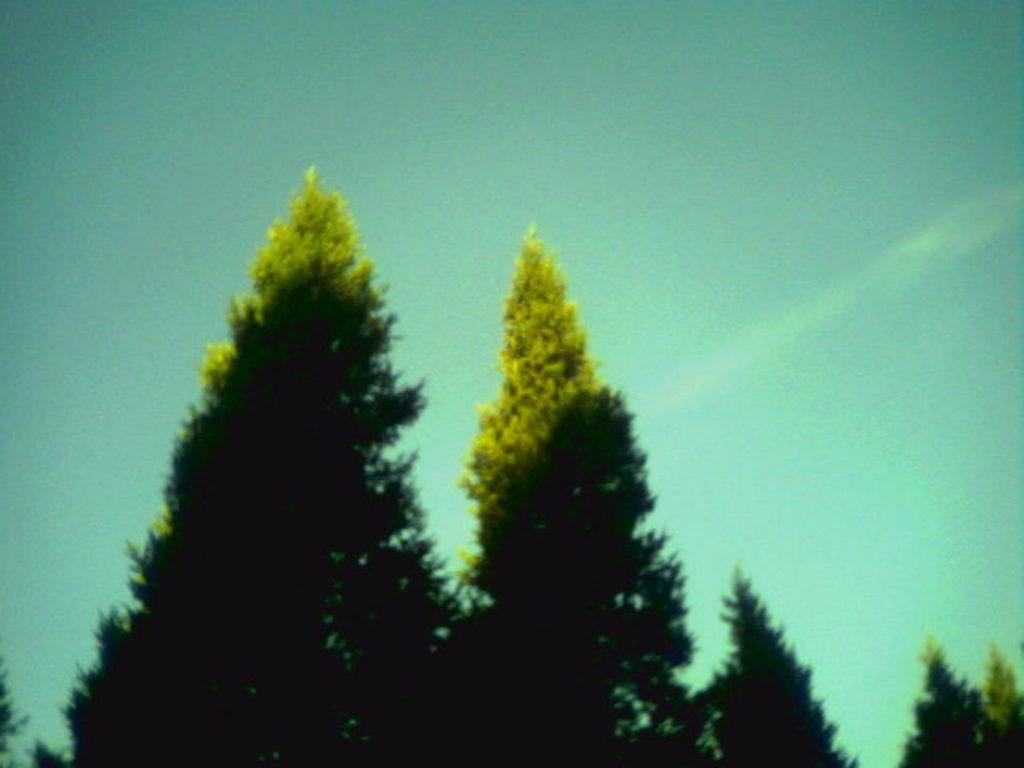What is located in the center of the image? There are trees in the center of the image. What can be seen in the background of the image? There is sky visible in the background of the image. How many friends can be seen sitting on the tree in the image? There are no friends sitting on the tree in the image, as there is no tree with people on it depicted. 